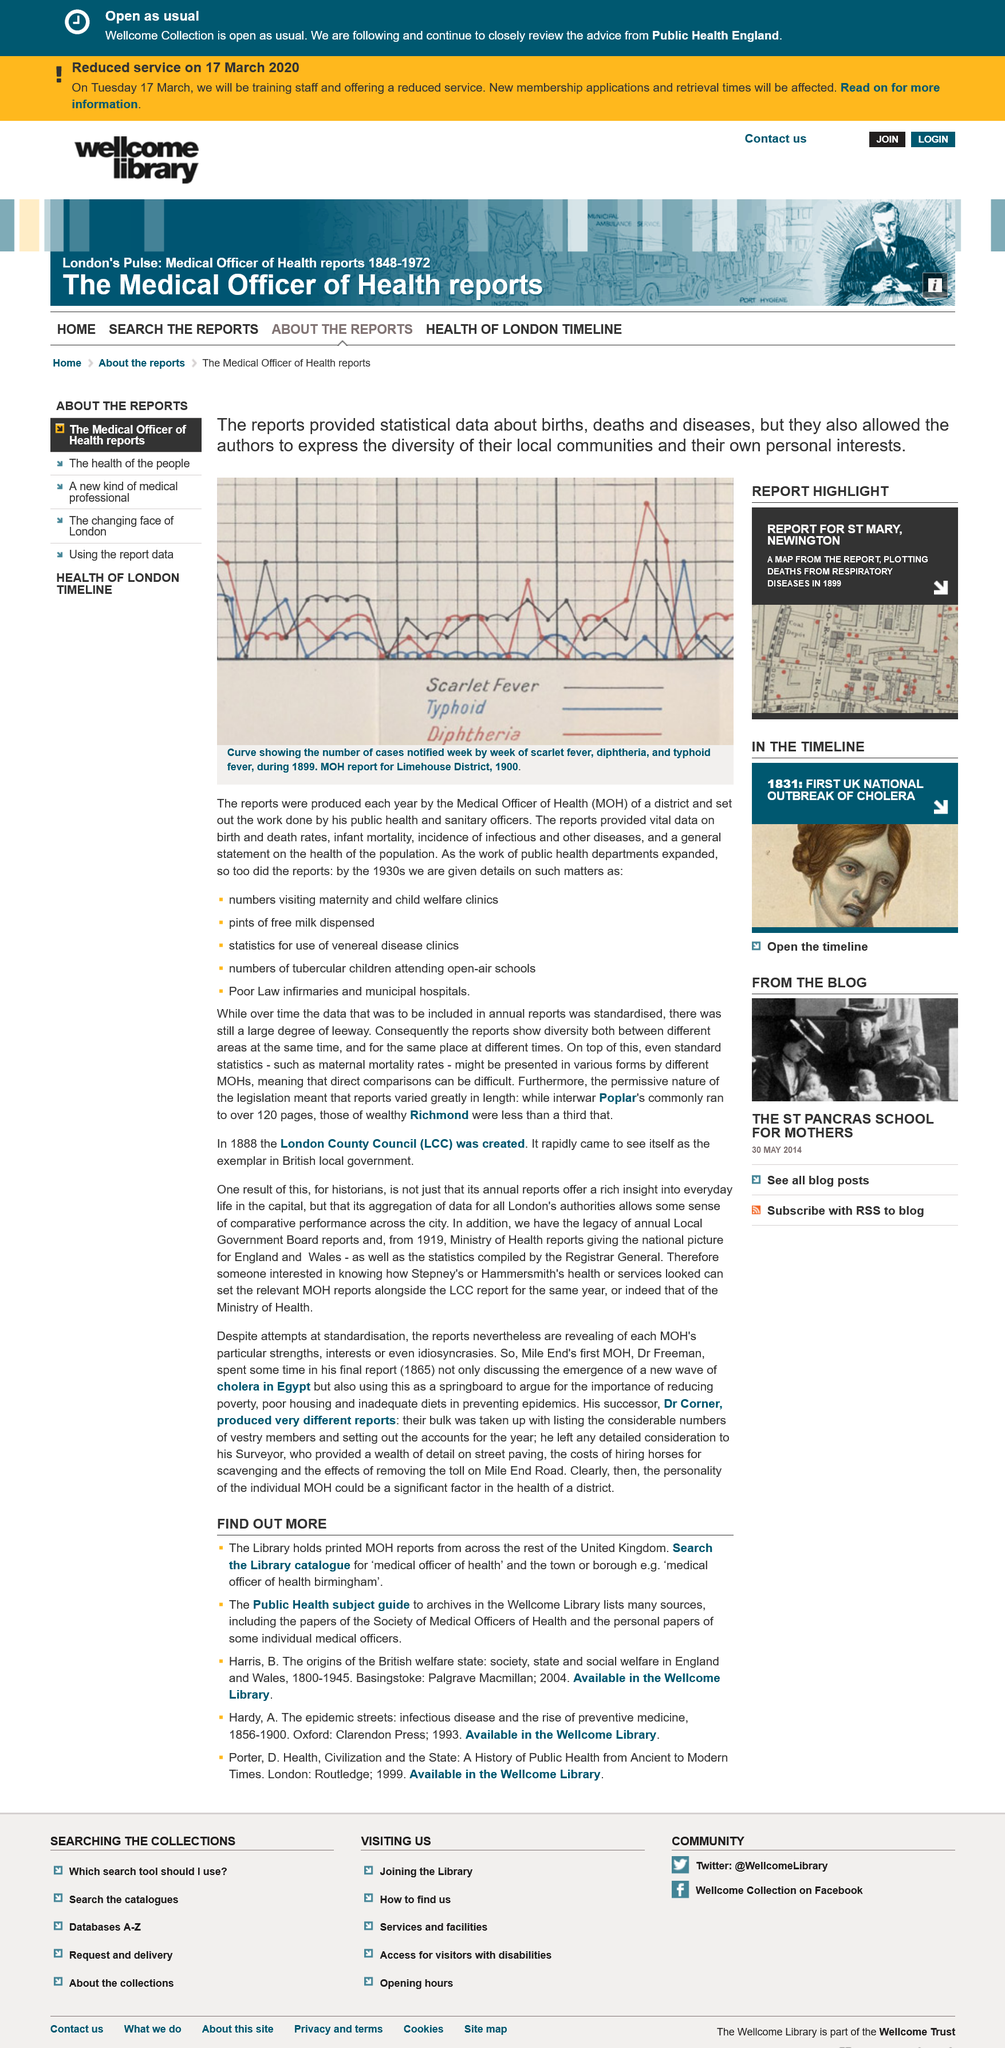Outline some significant characteristics in this image. What does the acronym MOH stand for? MOH is an abbreviation for Medical Officer of Health. The graph demonstrates the number of cases notified week by week of scarlet fever, diphtheria, and typhoid fever. The reports provided vital information on birth and death rates, infant mortality, incidence of infections and other diseases, which were crucial in determining the overall health and welfare of a population. 